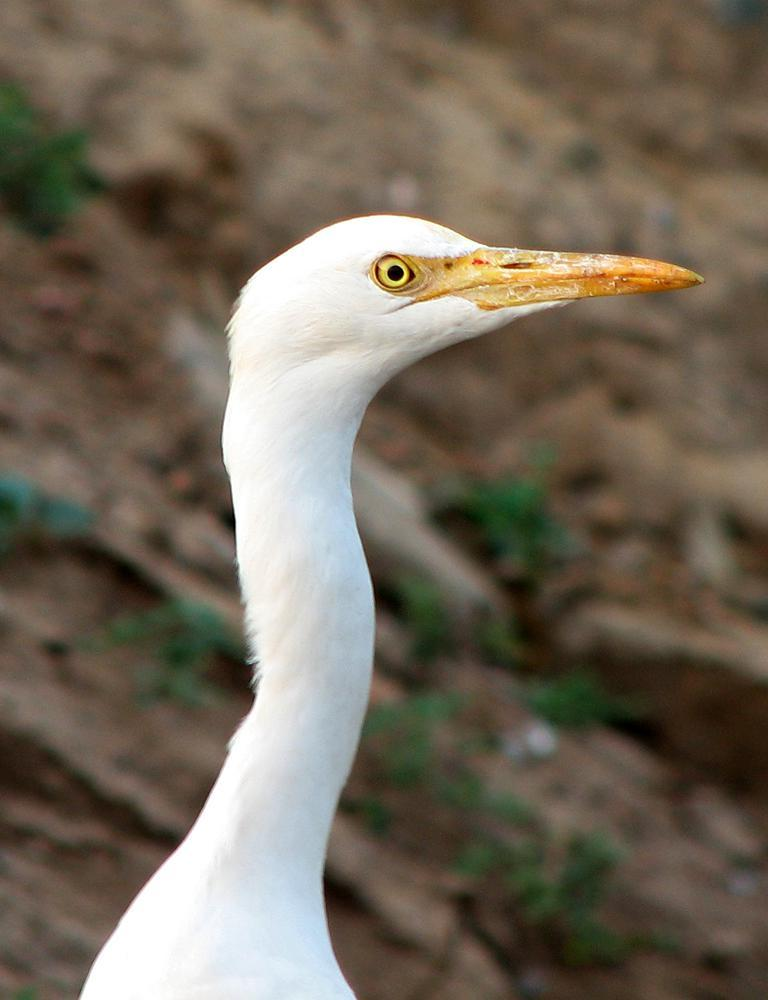What type of animal can be seen in the image? There is an animal with a long beak in the image. What type of credit card is the animal holding in the image? There is no credit card present in the image, as it features an animal with a long beak. 